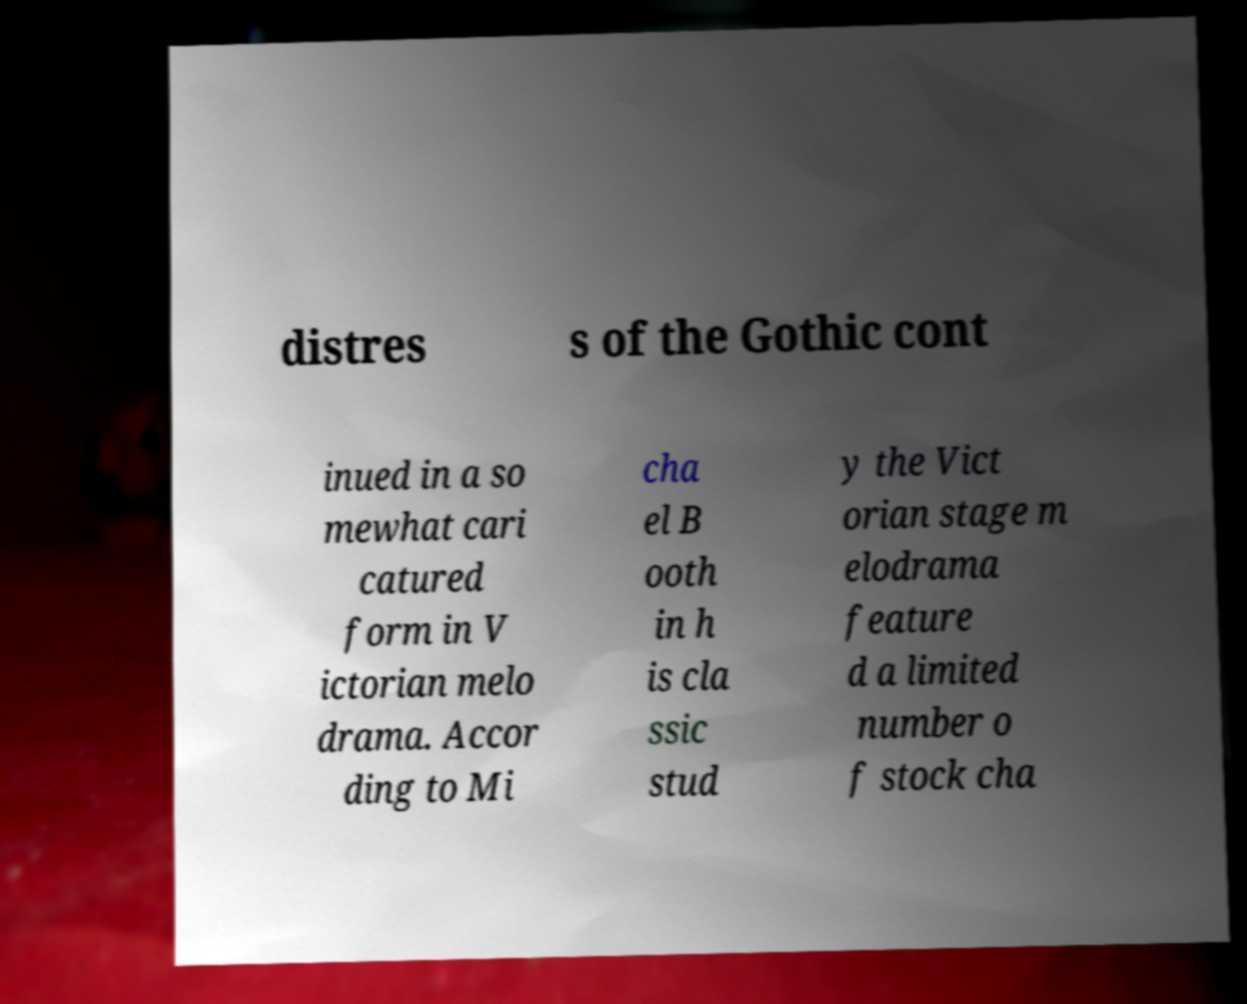Could you extract and type out the text from this image? distres s of the Gothic cont inued in a so mewhat cari catured form in V ictorian melo drama. Accor ding to Mi cha el B ooth in h is cla ssic stud y the Vict orian stage m elodrama feature d a limited number o f stock cha 